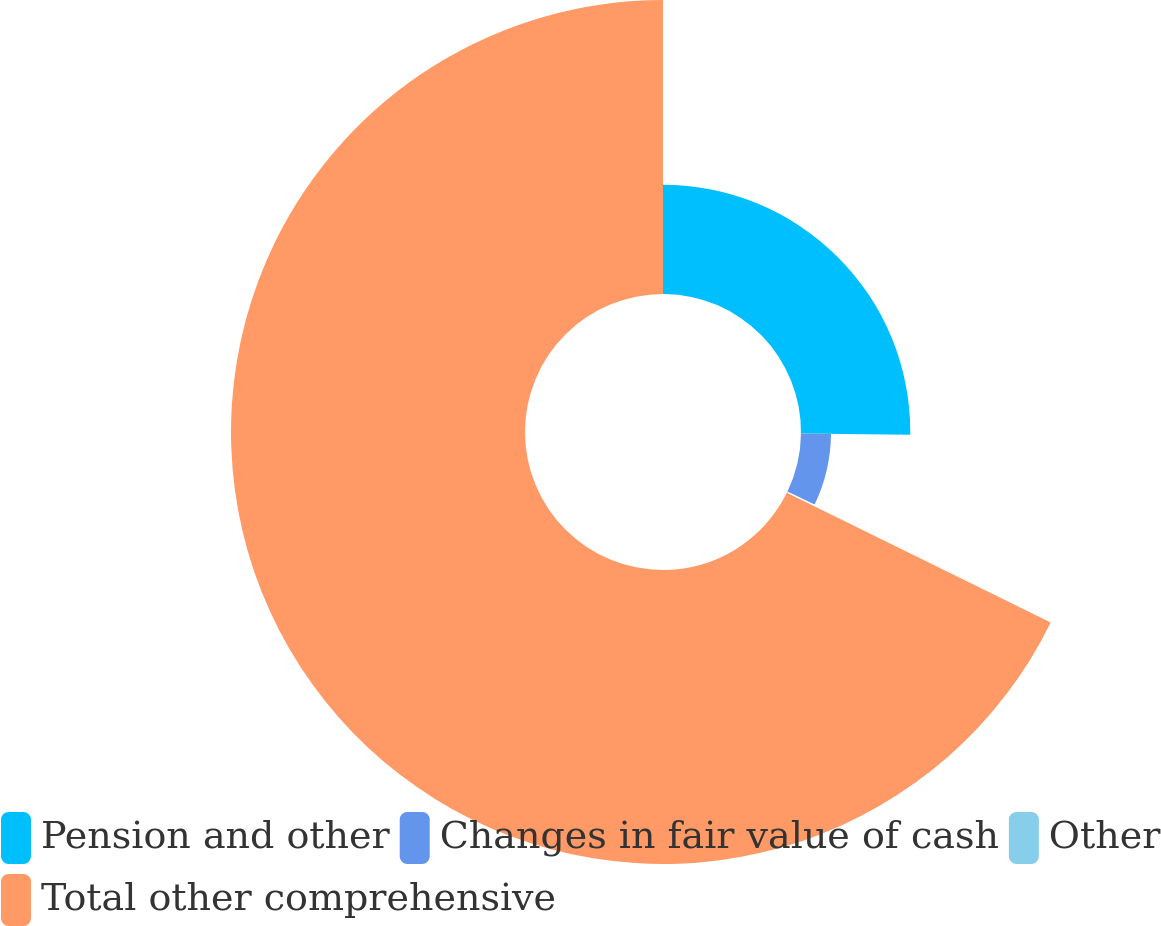Convert chart. <chart><loc_0><loc_0><loc_500><loc_500><pie_chart><fcel>Pension and other<fcel>Changes in fair value of cash<fcel>Other<fcel>Total other comprehensive<nl><fcel>25.18%<fcel>6.92%<fcel>0.17%<fcel>67.73%<nl></chart> 